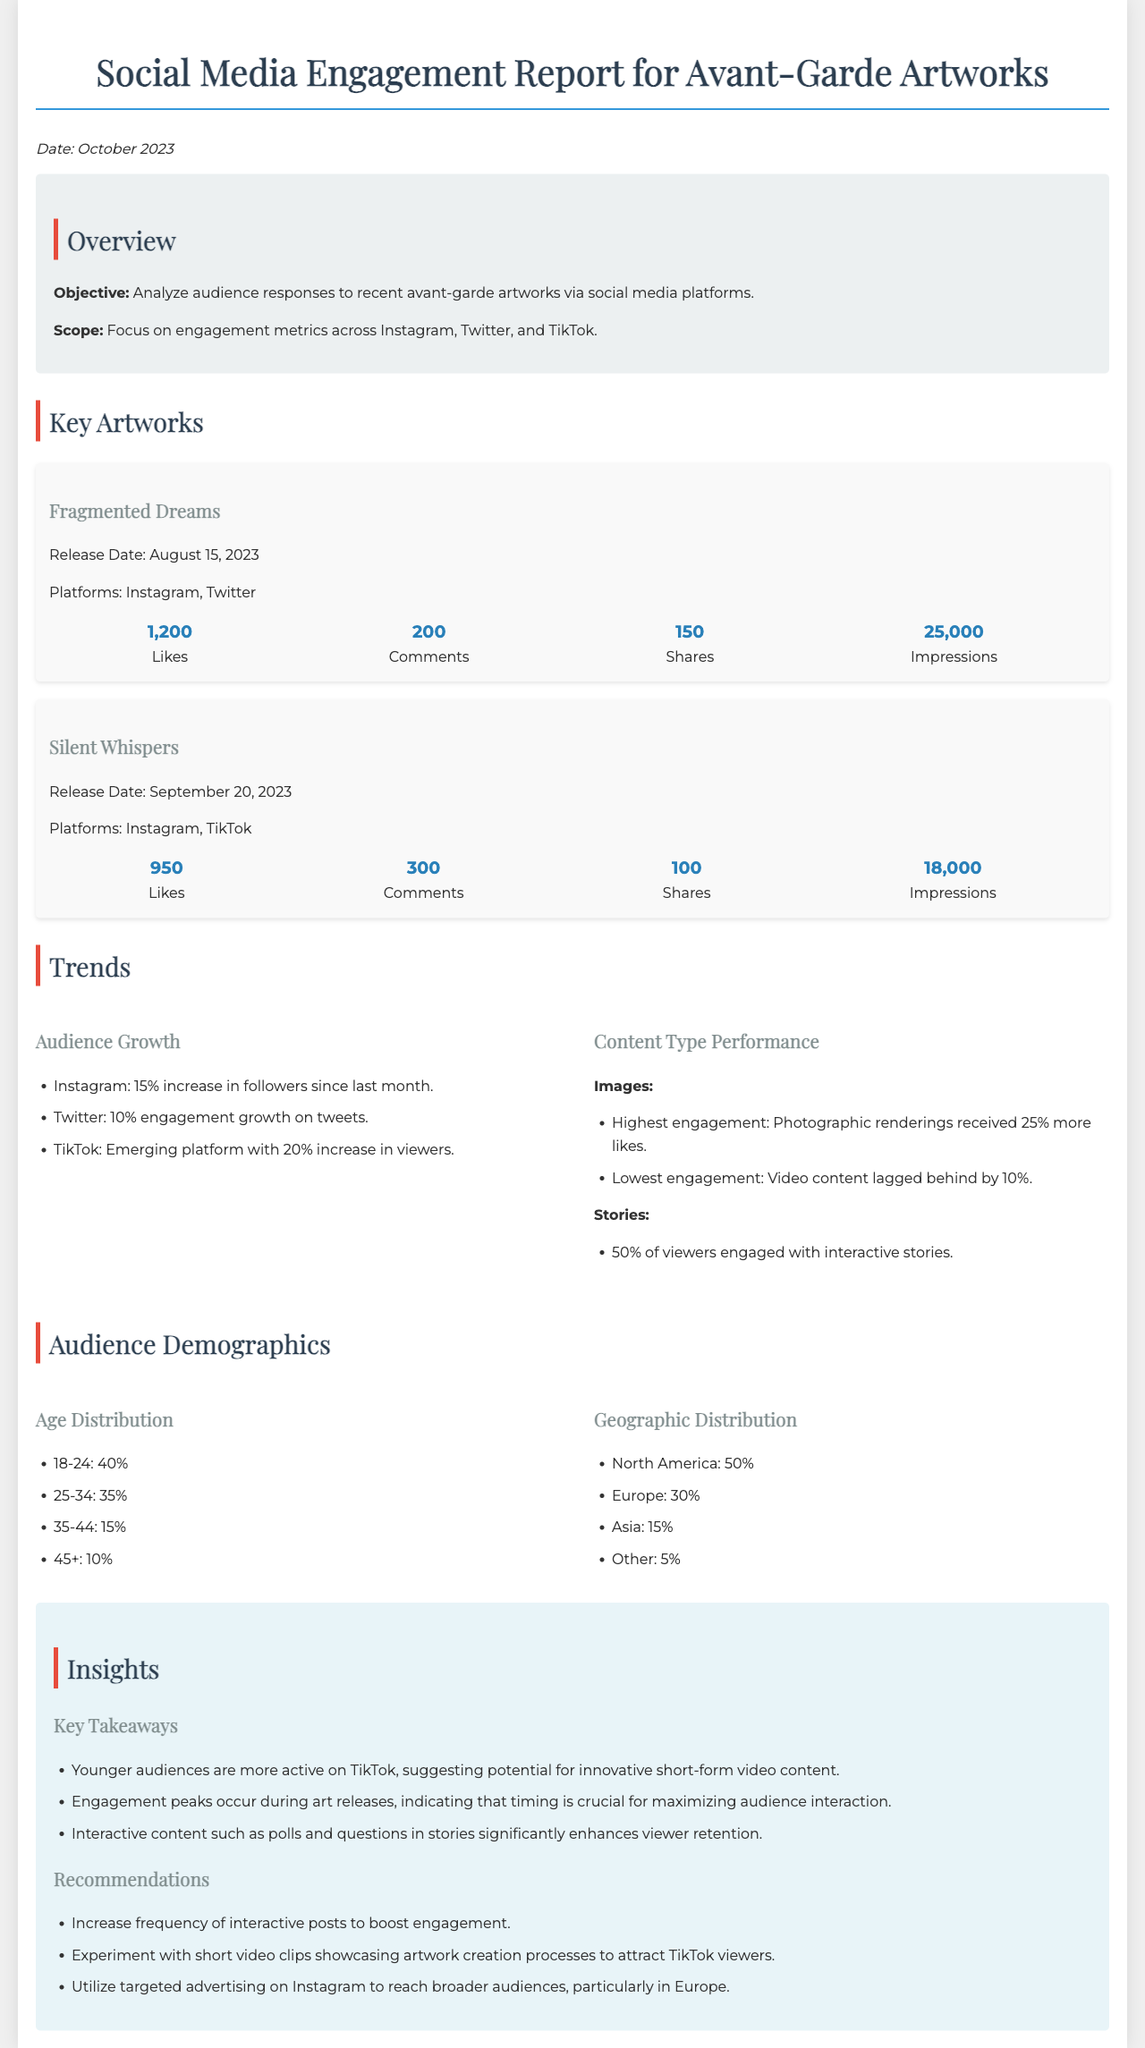What is the release date of "Fragmented Dreams"? The release date is specified in the document under the "Key Artworks" section for "Fragmented Dreams".
Answer: August 15, 2023 How many likes did "Silent Whispers" receive? The number of likes for "Silent Whispers" is listed in the engagement metrics under "Silent Whispers".
Answer: 950 What is the percentage of 18-24 age group in the audience demographics? The percentage for the 18-24 age group can be found in the "Audience Demographics" section.
Answer: 40% Which platform showed a 20% increase in viewers? This information is detailed under the "Audience Growth" insights related to platform performance.
Answer: TikTok What is one key takeaway from the insights section? Key takeaways can be found in the "Insights" section, listed under "Key Takeaways".
Answer: Younger audiences are more active on TikTok What percentage of viewers engaged with interactive stories? The engagement percentage of viewers with interactive stories is mentioned under "Content Type Performance".
Answer: 50% What type of content received 25% more likes? This information is provided in the "Content Type Performance" section regarding engagement metrics.
Answer: Photographic renderings What is the engagement number for shares of "Fragmented Dreams"? The engagement for shares is listed under the statistics for "Fragmented Dreams".
Answer: 150 What is the main objective of the report? The main objective is described in the "Overview" section of the document.
Answer: Analyze audience responses to recent avant-garde artworks 